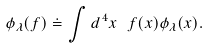<formula> <loc_0><loc_0><loc_500><loc_500>\phi _ { \lambda } ( f ) \doteq \int d ^ { \, 4 } x \ f ( x ) \phi _ { \lambda } ( x ) .</formula> 